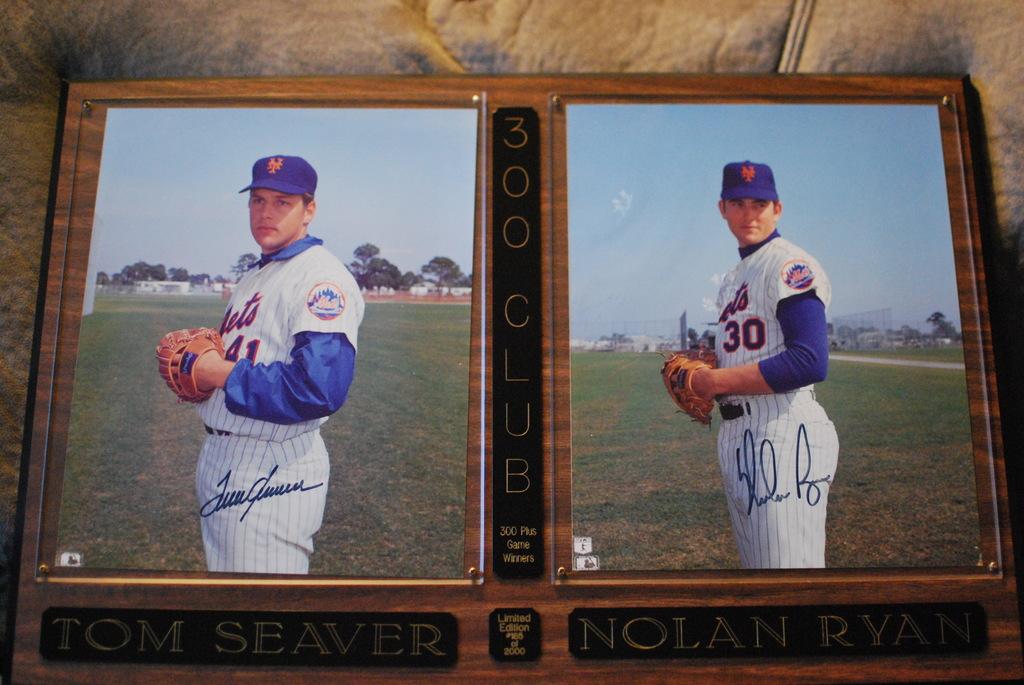What is the name of the player in the right photo?
Your answer should be very brief. Nolan ryan. What is written on the small square between the two mens names?
Make the answer very short. 300 club. 